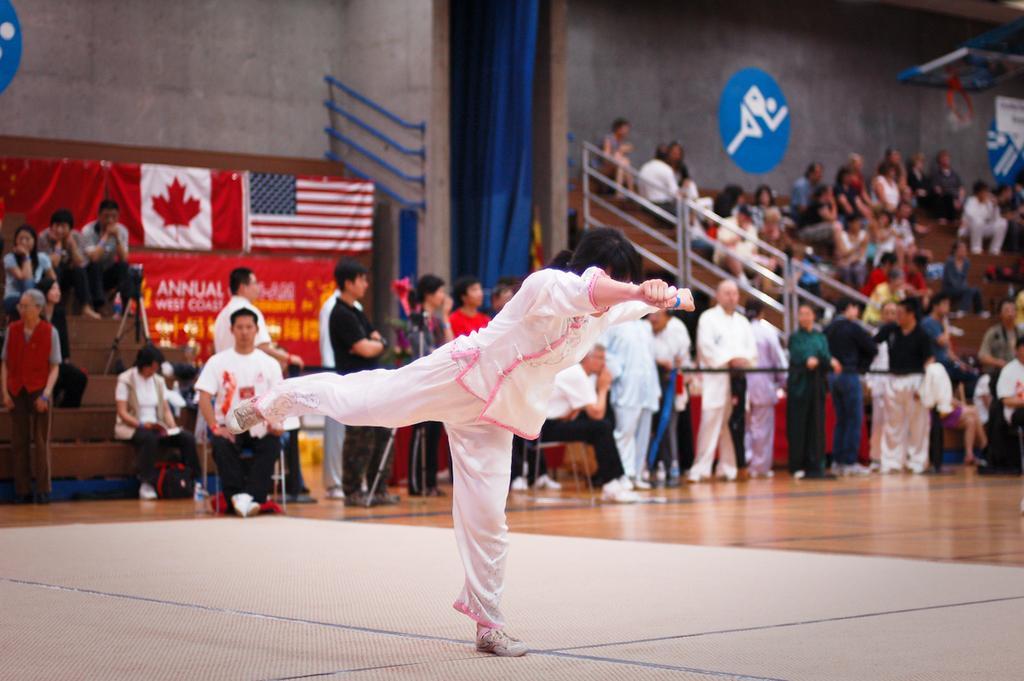In one or two sentences, can you explain what this image depicts? In this image there is a person standing on a single leg. Behind the person there are a few people sitting and a few standing. In the background there is a wall. To the left there is a banner with text on the wall. Above the banner there are flags on the wall. To the right there are symbols on the wall. In the center there is a curtain on the wall. At the bottom there is a mat on the floor. 